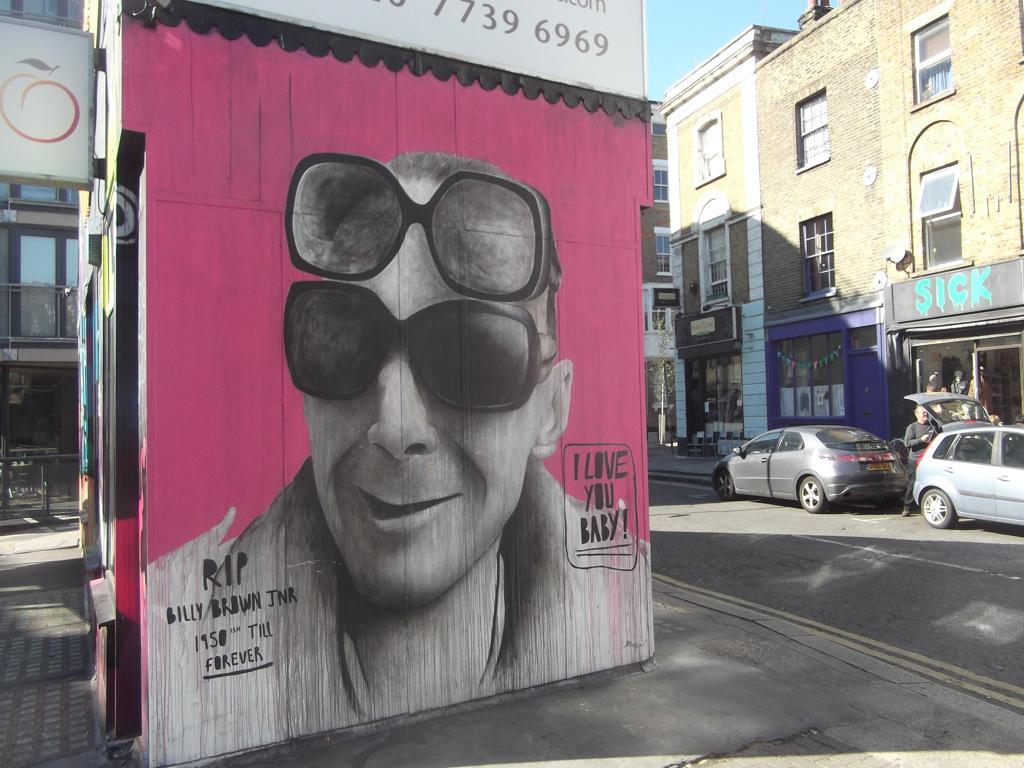Could you give a brief overview of what you see in this image? In this picture there is a painting of a person wearing goggles and there is something written on either sides of him and there are two cars and buildings in the right corner. 